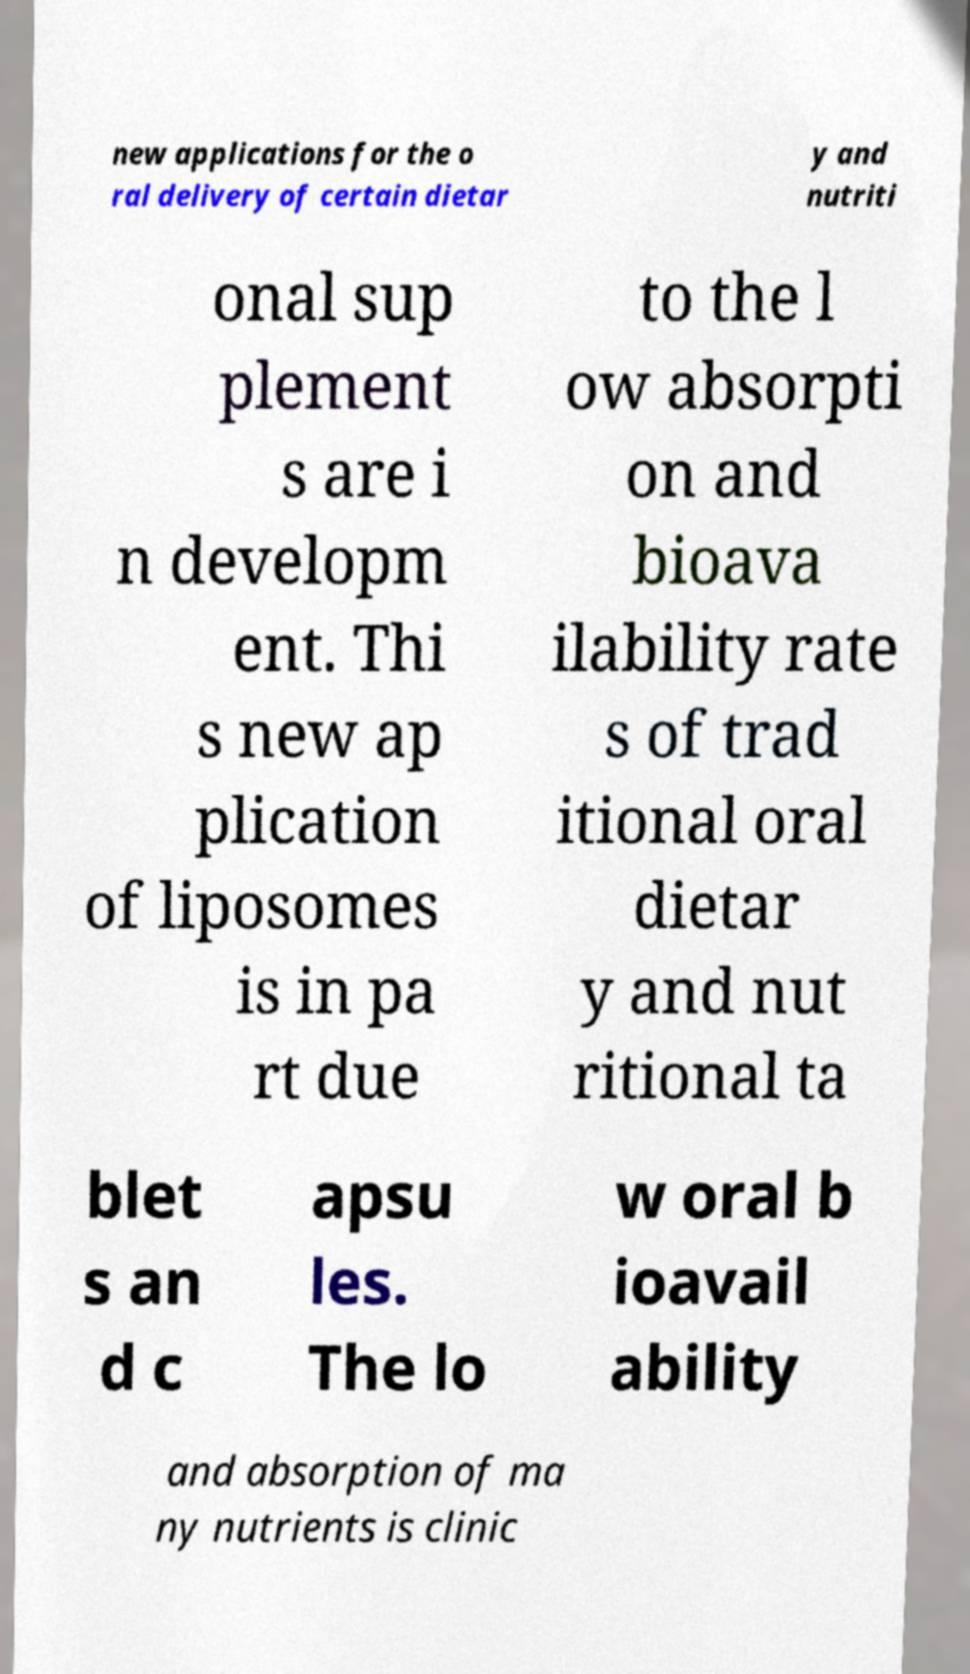There's text embedded in this image that I need extracted. Can you transcribe it verbatim? new applications for the o ral delivery of certain dietar y and nutriti onal sup plement s are i n developm ent. Thi s new ap plication of liposomes is in pa rt due to the l ow absorpti on and bioava ilability rate s of trad itional oral dietar y and nut ritional ta blet s an d c apsu les. The lo w oral b ioavail ability and absorption of ma ny nutrients is clinic 